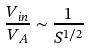Convert formula to latex. <formula><loc_0><loc_0><loc_500><loc_500>\frac { V _ { i n } } { V _ { A } } \sim \frac { 1 } { S ^ { 1 / 2 } }</formula> 